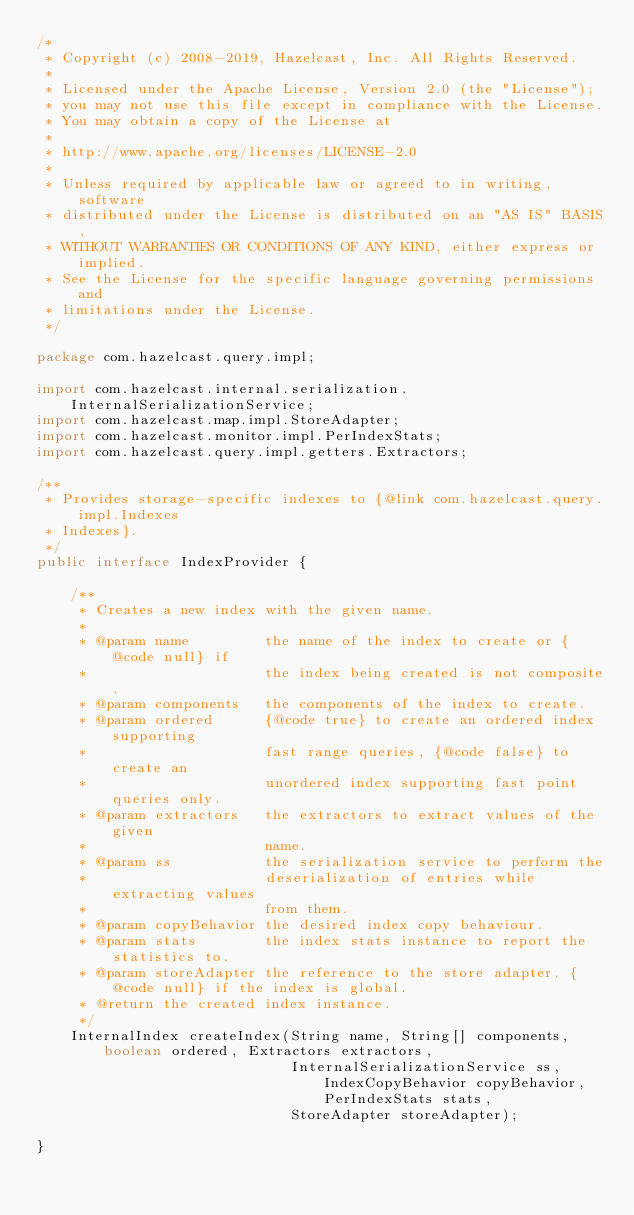Convert code to text. <code><loc_0><loc_0><loc_500><loc_500><_Java_>/*
 * Copyright (c) 2008-2019, Hazelcast, Inc. All Rights Reserved.
 *
 * Licensed under the Apache License, Version 2.0 (the "License");
 * you may not use this file except in compliance with the License.
 * You may obtain a copy of the License at
 *
 * http://www.apache.org/licenses/LICENSE-2.0
 *
 * Unless required by applicable law or agreed to in writing, software
 * distributed under the License is distributed on an "AS IS" BASIS,
 * WITHOUT WARRANTIES OR CONDITIONS OF ANY KIND, either express or implied.
 * See the License for the specific language governing permissions and
 * limitations under the License.
 */

package com.hazelcast.query.impl;

import com.hazelcast.internal.serialization.InternalSerializationService;
import com.hazelcast.map.impl.StoreAdapter;
import com.hazelcast.monitor.impl.PerIndexStats;
import com.hazelcast.query.impl.getters.Extractors;

/**
 * Provides storage-specific indexes to {@link com.hazelcast.query.impl.Indexes
 * Indexes}.
 */
public interface IndexProvider {

    /**
     * Creates a new index with the given name.
     *
     * @param name         the name of the index to create or {@code null} if
     *                     the index being created is not composite.
     * @param components   the components of the index to create.
     * @param ordered      {@code true} to create an ordered index supporting
     *                     fast range queries, {@code false} to create an
     *                     unordered index supporting fast point queries only.
     * @param extractors   the extractors to extract values of the given
     *                     name.
     * @param ss           the serialization service to perform the
     *                     deserialization of entries while extracting values
     *                     from them.
     * @param copyBehavior the desired index copy behaviour.
     * @param stats        the index stats instance to report the statistics to.
     * @param storeAdapter the reference to the store adapter. {@code null} if the index is global.
     * @return the created index instance.
     */
    InternalIndex createIndex(String name, String[] components, boolean ordered, Extractors extractors,
                              InternalSerializationService ss, IndexCopyBehavior copyBehavior, PerIndexStats stats,
                              StoreAdapter storeAdapter);

}
</code> 